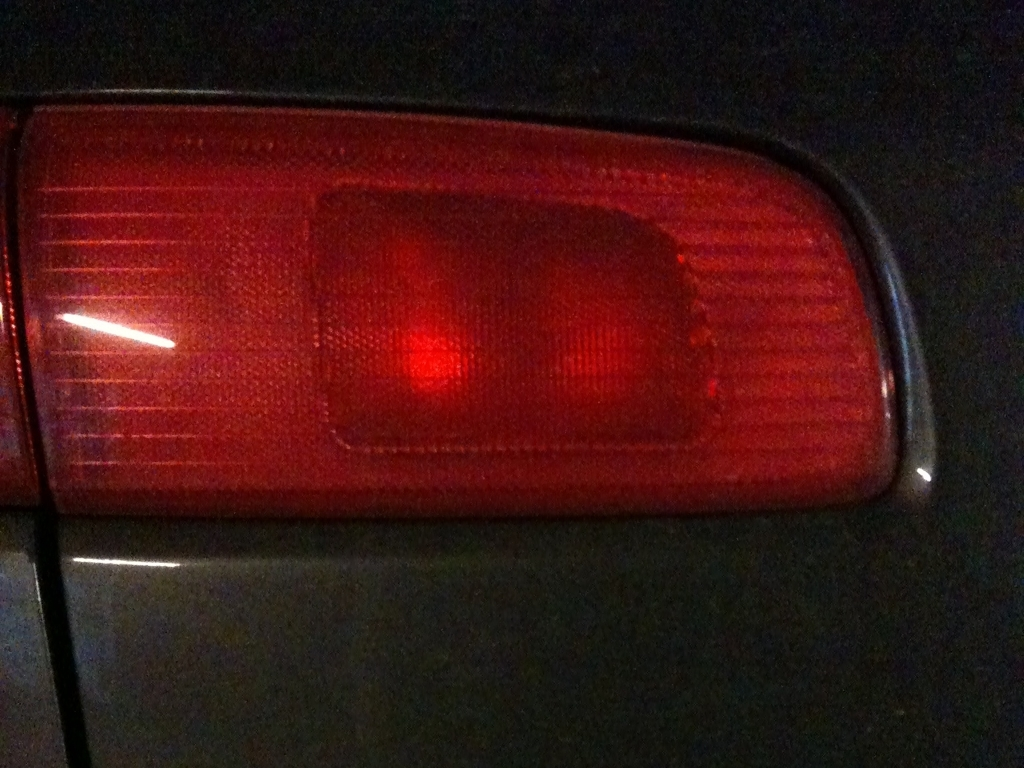How does this image reflect automotive safety features? The tail light is a critical safety feature on any vehicle, providing visual cues to other drivers on the road. Its bright red color is universally recognized to signal stopping or the intent to turn, reducing the risk of rear-end collisions. 